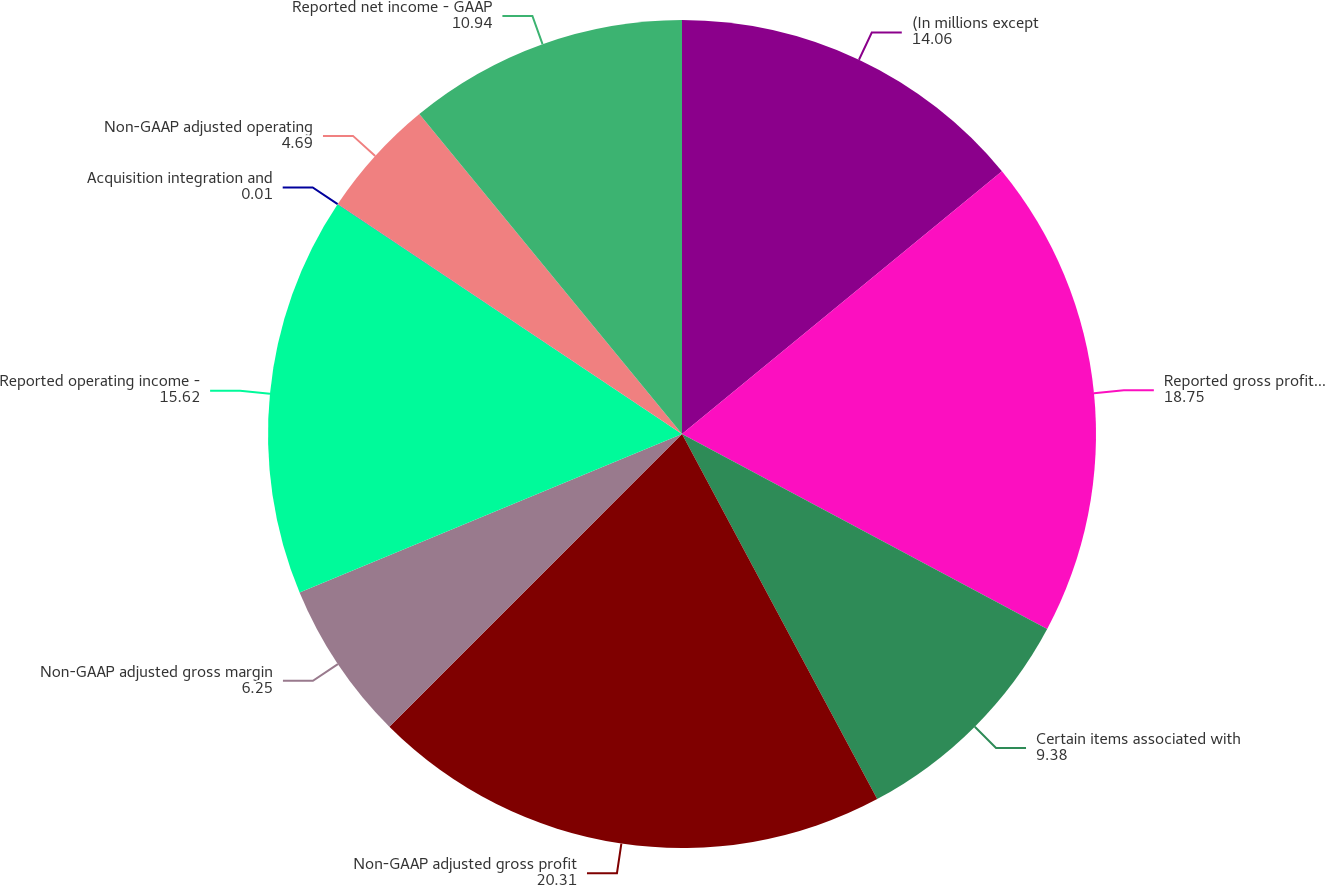<chart> <loc_0><loc_0><loc_500><loc_500><pie_chart><fcel>(In millions except<fcel>Reported gross profit - GAAP<fcel>Certain items associated with<fcel>Non-GAAP adjusted gross profit<fcel>Non-GAAP adjusted gross margin<fcel>Reported operating income -<fcel>Acquisition integration and<fcel>Non-GAAP adjusted operating<fcel>Reported net income - GAAP<nl><fcel>14.06%<fcel>18.75%<fcel>9.38%<fcel>20.31%<fcel>6.25%<fcel>15.62%<fcel>0.01%<fcel>4.69%<fcel>10.94%<nl></chart> 